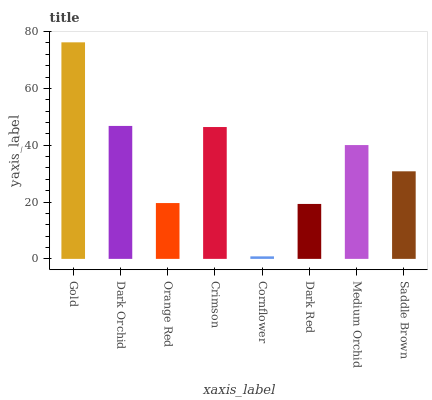Is Cornflower the minimum?
Answer yes or no. Yes. Is Gold the maximum?
Answer yes or no. Yes. Is Dark Orchid the minimum?
Answer yes or no. No. Is Dark Orchid the maximum?
Answer yes or no. No. Is Gold greater than Dark Orchid?
Answer yes or no. Yes. Is Dark Orchid less than Gold?
Answer yes or no. Yes. Is Dark Orchid greater than Gold?
Answer yes or no. No. Is Gold less than Dark Orchid?
Answer yes or no. No. Is Medium Orchid the high median?
Answer yes or no. Yes. Is Saddle Brown the low median?
Answer yes or no. Yes. Is Orange Red the high median?
Answer yes or no. No. Is Crimson the low median?
Answer yes or no. No. 